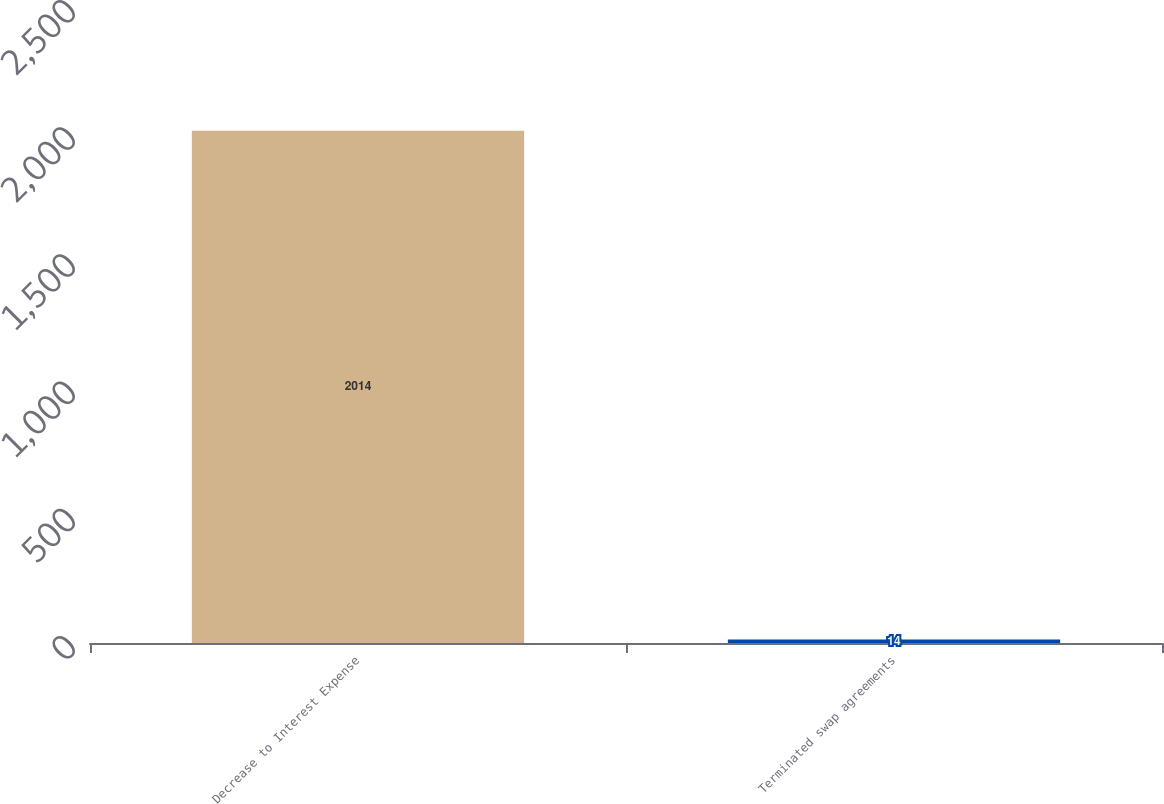<chart> <loc_0><loc_0><loc_500><loc_500><bar_chart><fcel>Decrease to Interest Expense<fcel>Terminated swap agreements<nl><fcel>2014<fcel>14<nl></chart> 